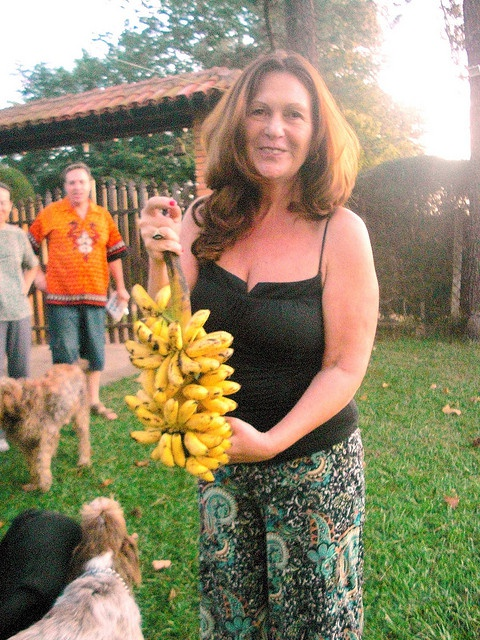Describe the objects in this image and their specific colors. I can see people in white, black, salmon, and gray tones, banana in white, orange, gold, and olive tones, people in white, red, orange, lightpink, and gray tones, dog in white, lightgray, tan, darkgray, and gray tones, and dog in white, tan, and gray tones in this image. 